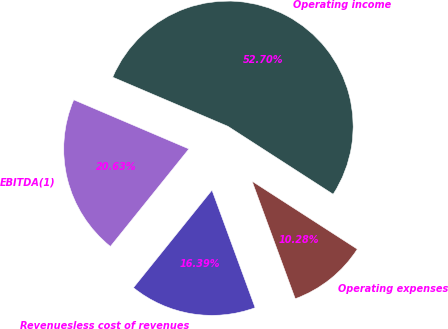Convert chart. <chart><loc_0><loc_0><loc_500><loc_500><pie_chart><fcel>Revenuesless cost of revenues<fcel>Operating expenses<fcel>Operating income<fcel>EBITDA(1)<nl><fcel>16.39%<fcel>10.28%<fcel>52.71%<fcel>20.63%<nl></chart> 